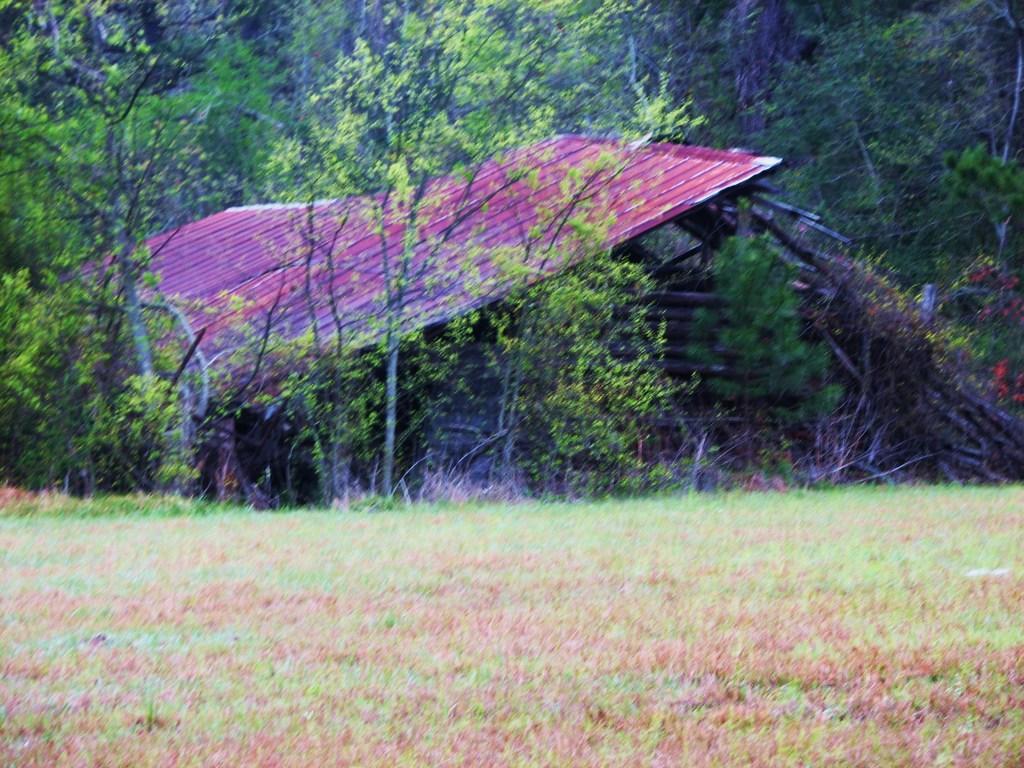In one or two sentences, can you explain what this image depicts? In the middle of the image I can see a roofing sheet and wooden objects. In the front of the image land is covered with grass. In the background of the image there are trees.   